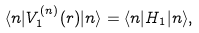Convert formula to latex. <formula><loc_0><loc_0><loc_500><loc_500>\langle n | V ^ { ( n ) } _ { 1 } ( { r } ) | n \rangle = \langle n | H _ { 1 } | n \rangle ,</formula> 